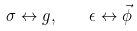Convert formula to latex. <formula><loc_0><loc_0><loc_500><loc_500>\sigma \leftrightarrow g , \quad \epsilon \leftrightarrow \vec { \phi }</formula> 